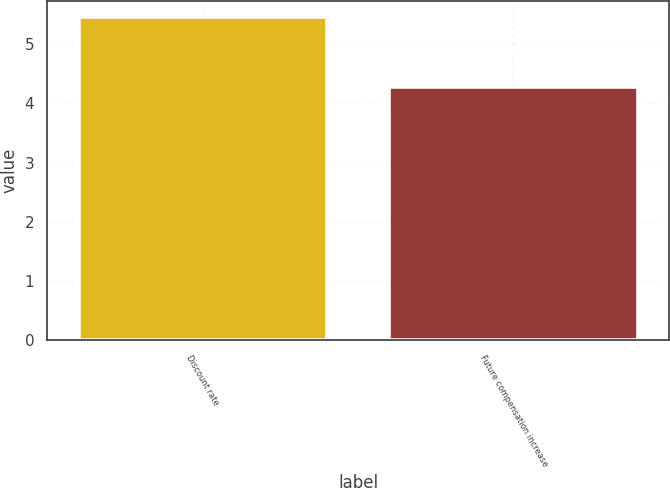Convert chart to OTSL. <chart><loc_0><loc_0><loc_500><loc_500><bar_chart><fcel>Discount rate<fcel>Future compensation increase<nl><fcel>5.46<fcel>4.28<nl></chart> 